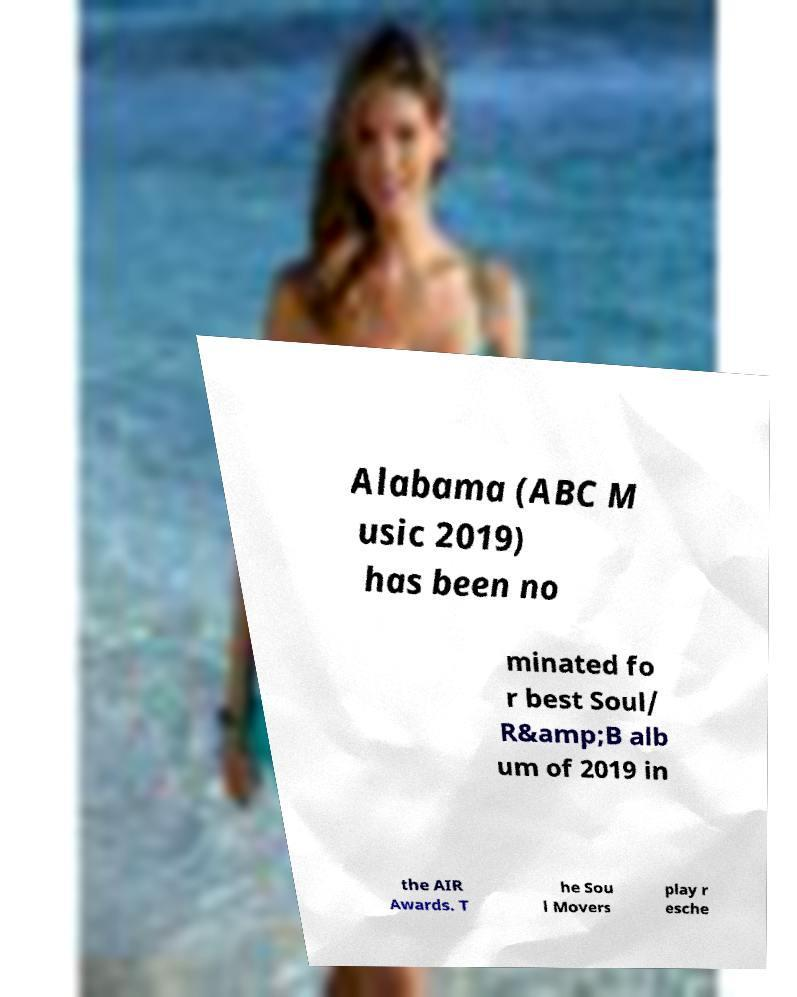Can you accurately transcribe the text from the provided image for me? Alabama (ABC M usic 2019) has been no minated fo r best Soul/ R&amp;B alb um of 2019 in the AIR Awards. T he Sou l Movers play r esche 